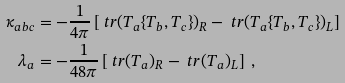Convert formula to latex. <formula><loc_0><loc_0><loc_500><loc_500>\kappa _ { a b c } & = - \frac { 1 } { 4 \pi } \left [ \ t r ( T _ { a } \{ T _ { b } , T _ { c } \} ) _ { R } - \ t r ( T _ { a } \{ T _ { b } , T _ { c } \} ) _ { L } \right ] \\ \lambda _ { a } & = - \frac { 1 } { 4 8 \pi } \left [ \ t r ( T _ { a } ) _ { R } - \ t r ( T _ { a } ) _ { L } \right ] \ ,</formula> 